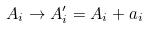<formula> <loc_0><loc_0><loc_500><loc_500>A _ { i } \rightarrow A _ { i } ^ { \prime } = A _ { i } + a _ { i }</formula> 